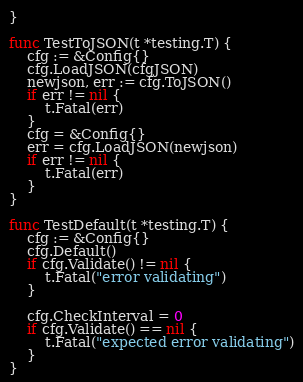Convert code to text. <code><loc_0><loc_0><loc_500><loc_500><_Go_>}

func TestToJSON(t *testing.T) {
	cfg := &Config{}
	cfg.LoadJSON(cfgJSON)
	newjson, err := cfg.ToJSON()
	if err != nil {
		t.Fatal(err)
	}
	cfg = &Config{}
	err = cfg.LoadJSON(newjson)
	if err != nil {
		t.Fatal(err)
	}
}

func TestDefault(t *testing.T) {
	cfg := &Config{}
	cfg.Default()
	if cfg.Validate() != nil {
		t.Fatal("error validating")
	}

	cfg.CheckInterval = 0
	if cfg.Validate() == nil {
		t.Fatal("expected error validating")
	}
}
</code> 